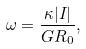Convert formula to latex. <formula><loc_0><loc_0><loc_500><loc_500>\omega = \frac { \kappa | I | } { G R _ { 0 } } ,</formula> 